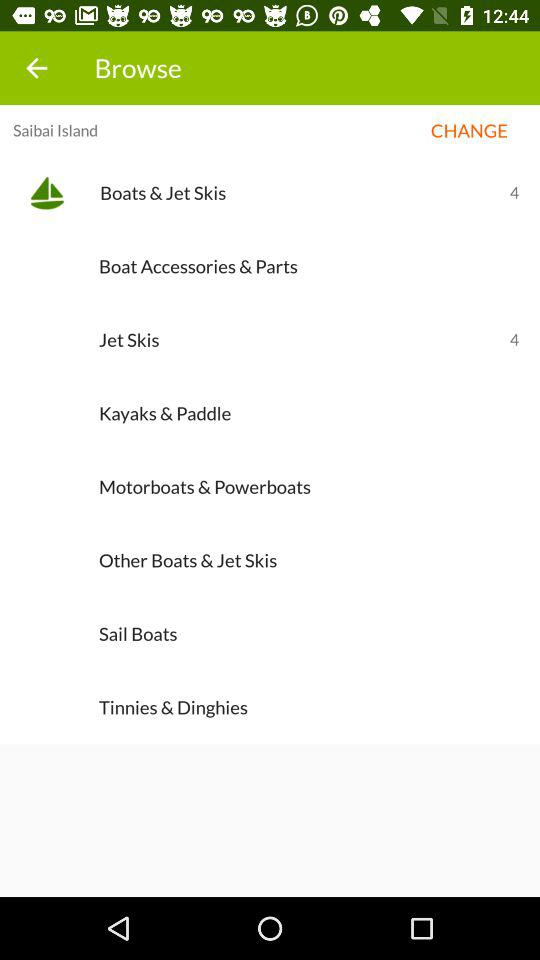Where is Saibai Island located?
When the provided information is insufficient, respond with <no answer>. <no answer> 